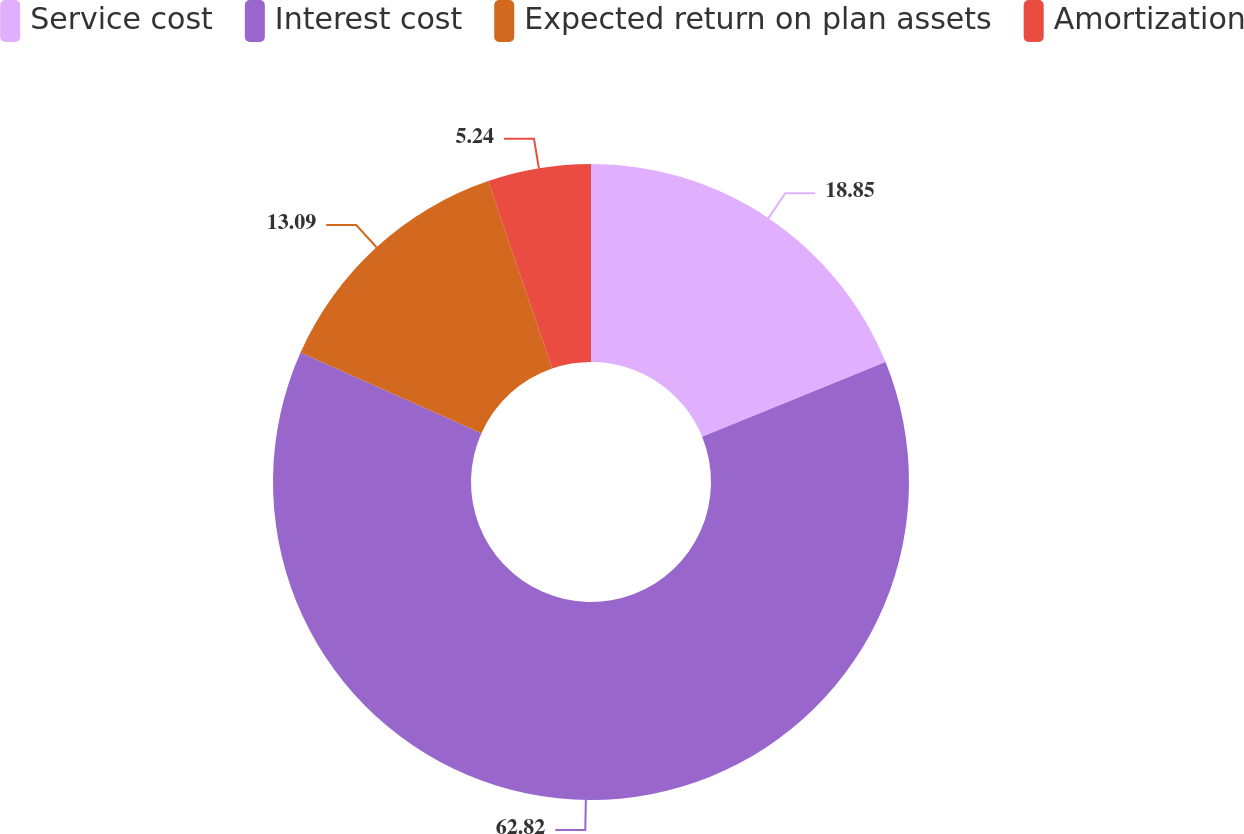<chart> <loc_0><loc_0><loc_500><loc_500><pie_chart><fcel>Service cost<fcel>Interest cost<fcel>Expected return on plan assets<fcel>Amortization<nl><fcel>18.85%<fcel>62.83%<fcel>13.09%<fcel>5.24%<nl></chart> 